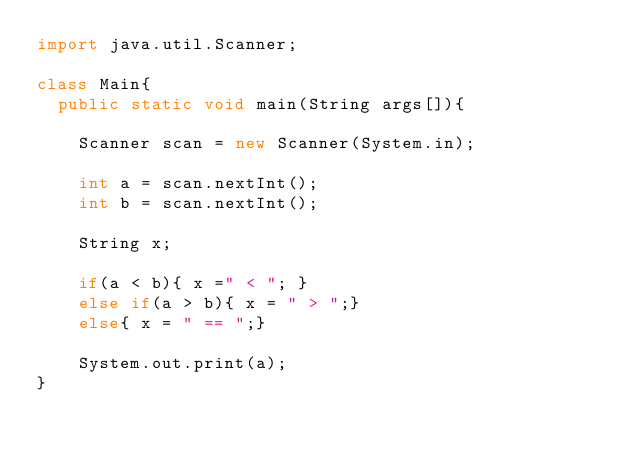<code> <loc_0><loc_0><loc_500><loc_500><_Java_>import java.util.Scanner;

class Main{
  public static void main(String args[]){

    Scanner scan = new Scanner(System.in);

    int a = scan.nextInt();
    int b = scan.nextInt();

    String x;
    
    if(a < b){ x =" < "; }
    else if(a > b){ x = " > ";}
    else{ x = " == ";}

    System.out.print(a);
}</code> 